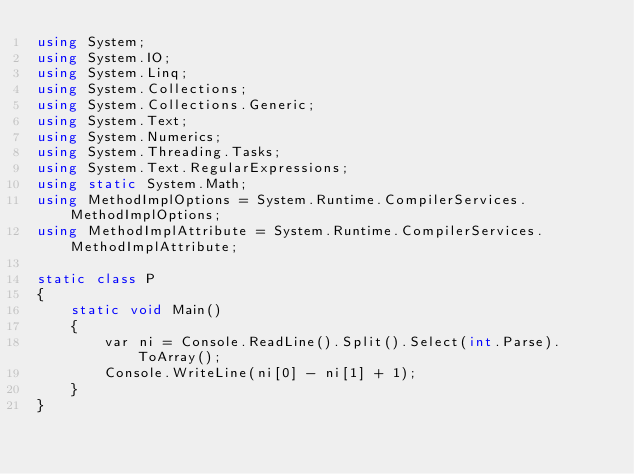<code> <loc_0><loc_0><loc_500><loc_500><_C#_>using System;
using System.IO;
using System.Linq;
using System.Collections;
using System.Collections.Generic;
using System.Text;
using System.Numerics;
using System.Threading.Tasks;
using System.Text.RegularExpressions;
using static System.Math;
using MethodImplOptions = System.Runtime.CompilerServices.MethodImplOptions;
using MethodImplAttribute = System.Runtime.CompilerServices.MethodImplAttribute;

static class P
{
    static void Main()
    {
        var ni = Console.ReadLine().Split().Select(int.Parse).ToArray();
        Console.WriteLine(ni[0] - ni[1] + 1);
    }
}
</code> 